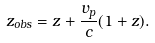Convert formula to latex. <formula><loc_0><loc_0><loc_500><loc_500>z _ { o b s } = z + \frac { v _ { p } } { c } ( 1 + z ) .</formula> 